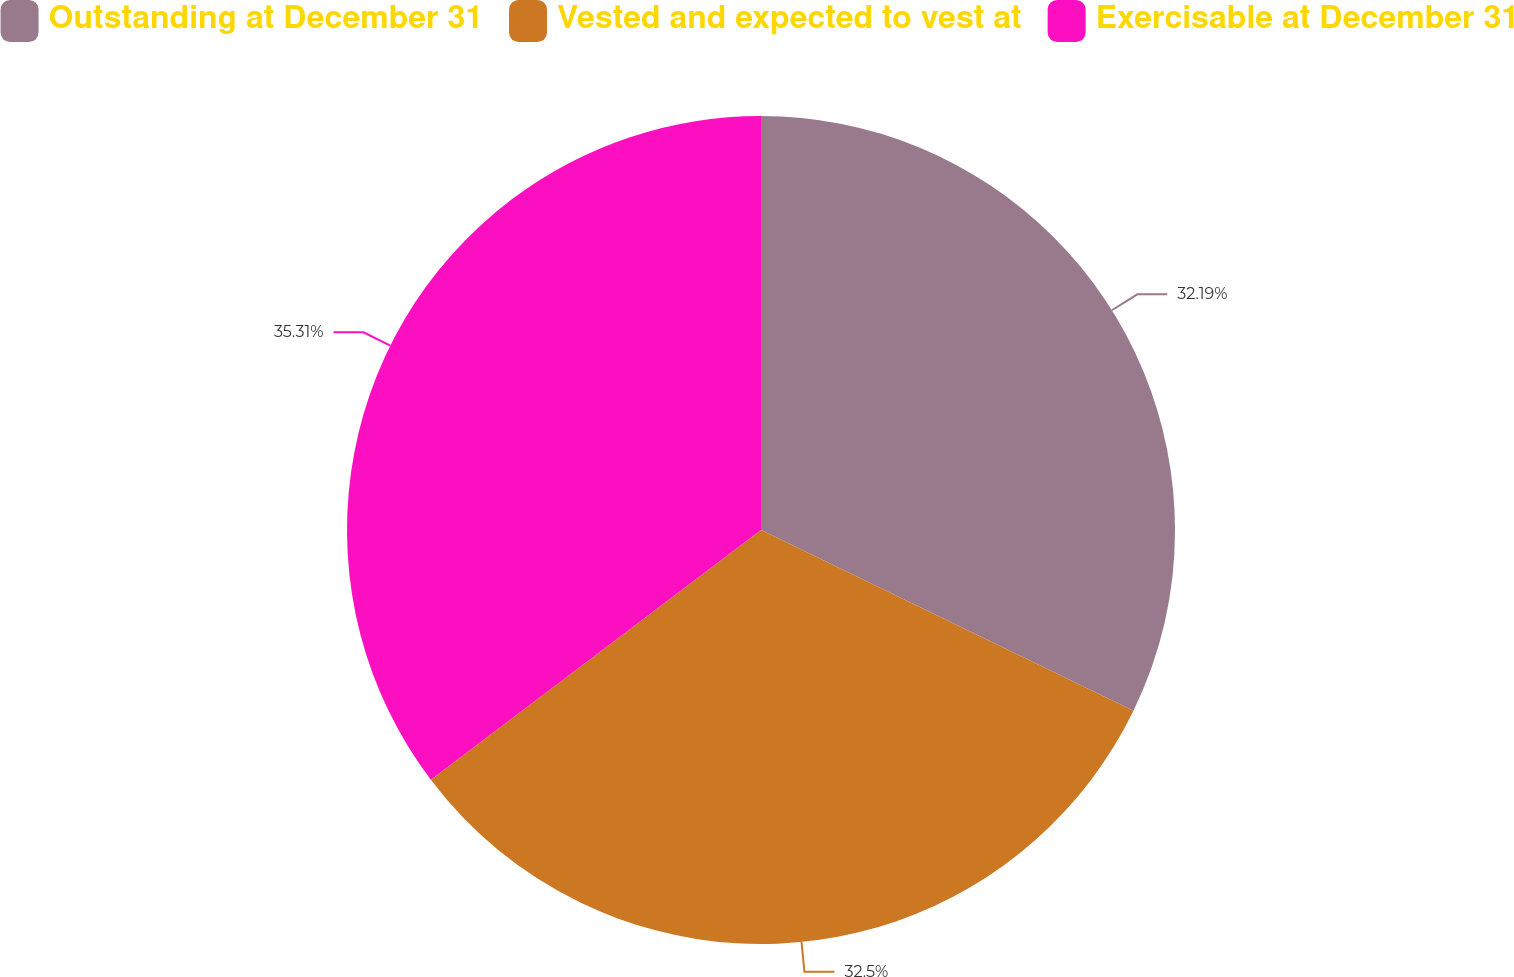Convert chart to OTSL. <chart><loc_0><loc_0><loc_500><loc_500><pie_chart><fcel>Outstanding at December 31<fcel>Vested and expected to vest at<fcel>Exercisable at December 31<nl><fcel>32.19%<fcel>32.5%<fcel>35.31%<nl></chart> 